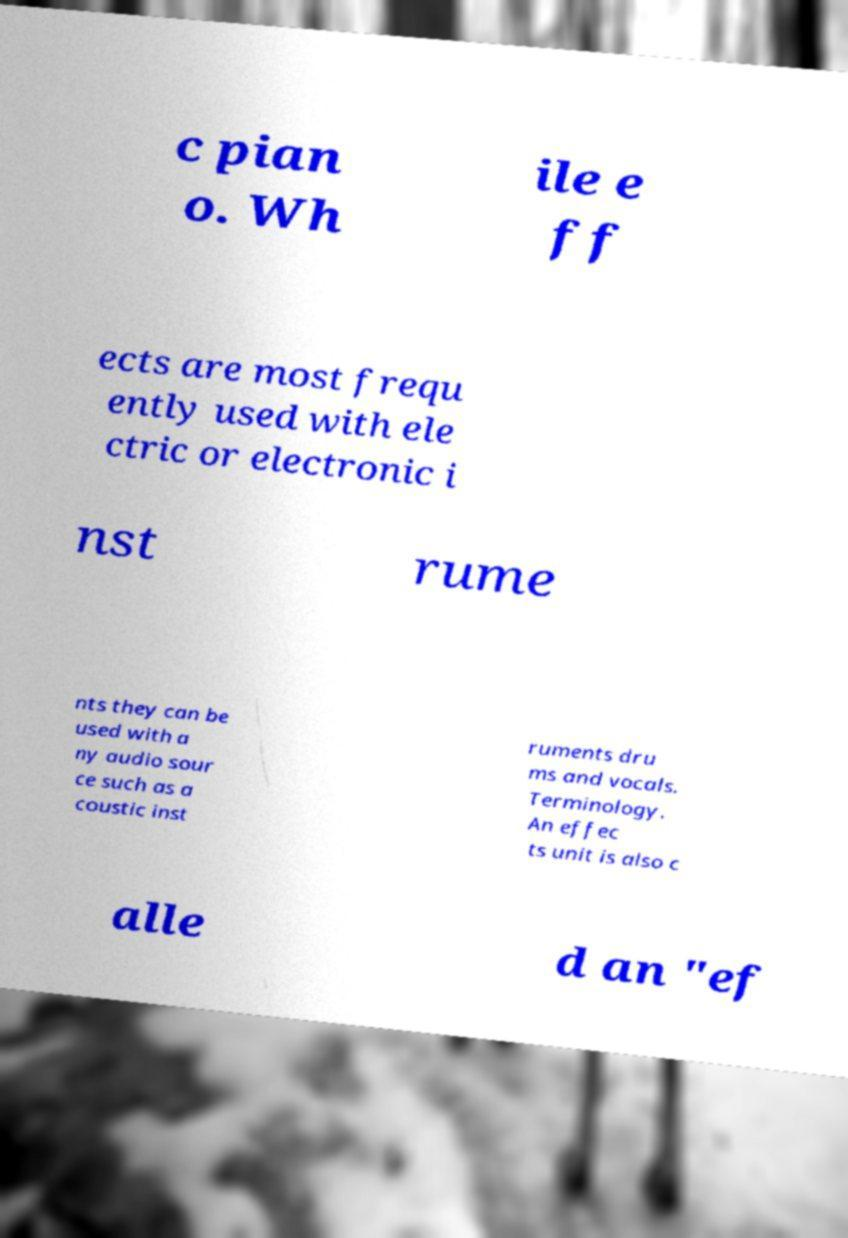Can you read and provide the text displayed in the image?This photo seems to have some interesting text. Can you extract and type it out for me? c pian o. Wh ile e ff ects are most frequ ently used with ele ctric or electronic i nst rume nts they can be used with a ny audio sour ce such as a coustic inst ruments dru ms and vocals. Terminology. An effec ts unit is also c alle d an "ef 